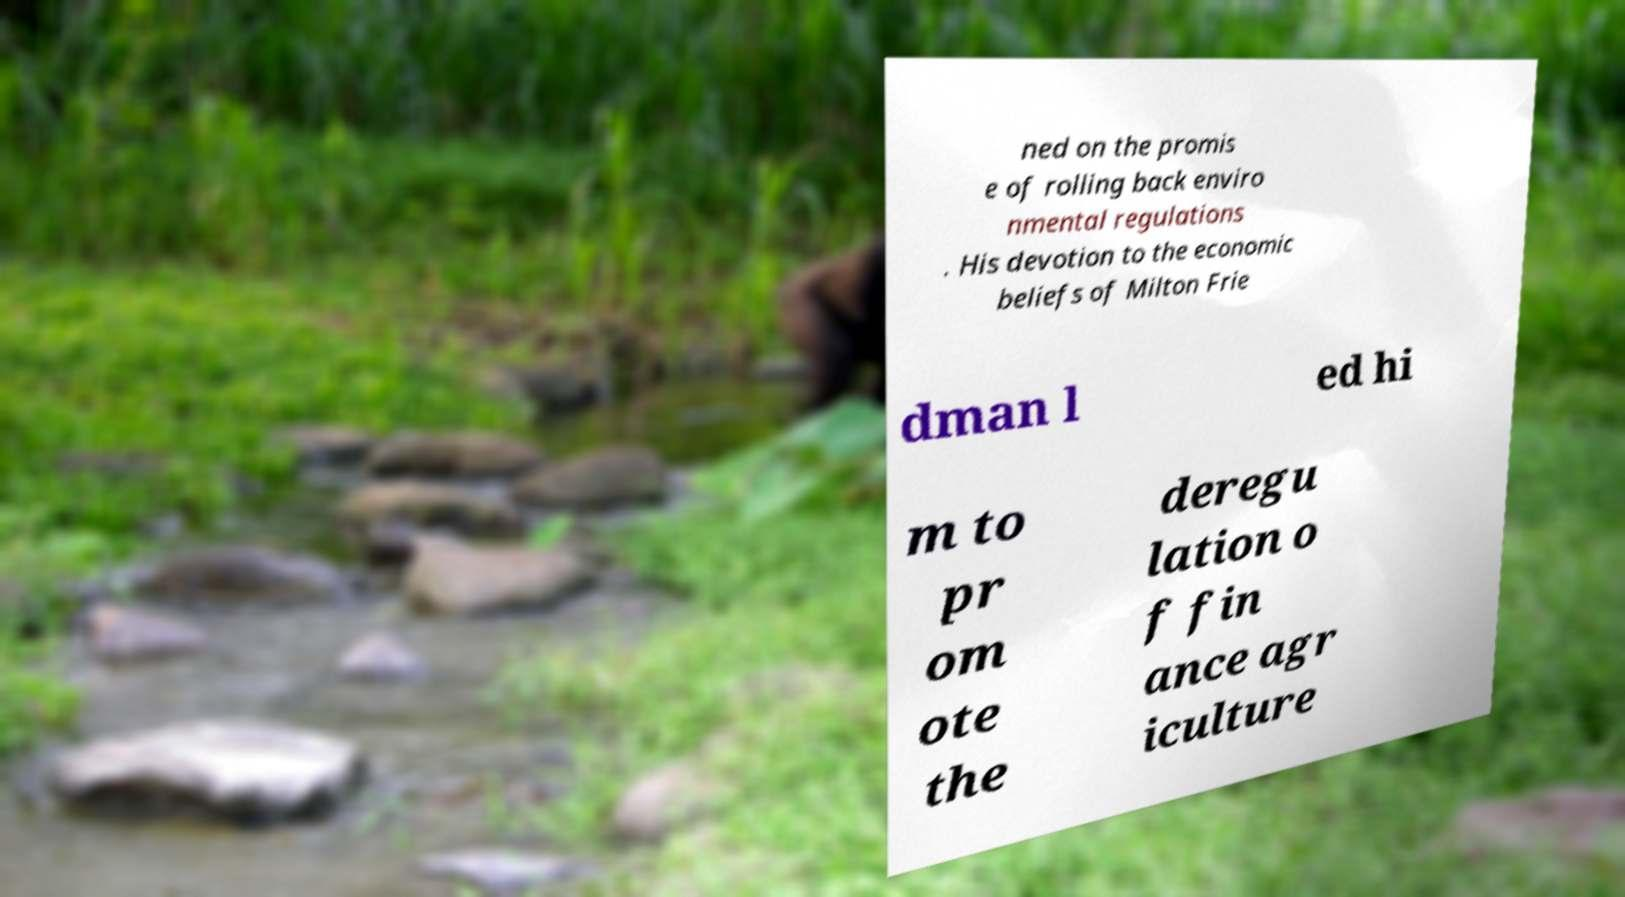Could you extract and type out the text from this image? ned on the promis e of rolling back enviro nmental regulations . His devotion to the economic beliefs of Milton Frie dman l ed hi m to pr om ote the deregu lation o f fin ance agr iculture 